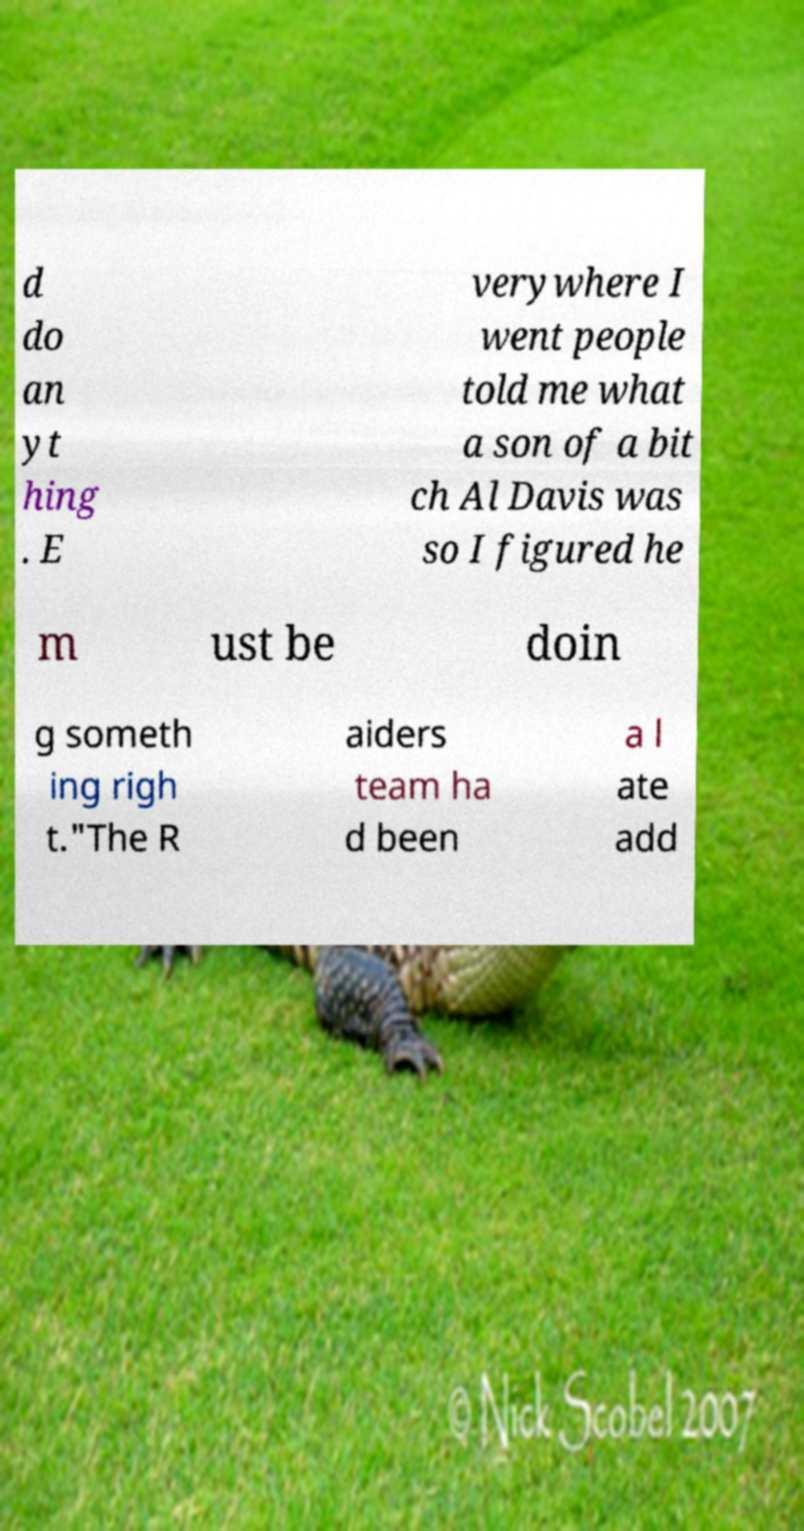What messages or text are displayed in this image? I need them in a readable, typed format. d do an yt hing . E verywhere I went people told me what a son of a bit ch Al Davis was so I figured he m ust be doin g someth ing righ t."The R aiders team ha d been a l ate add 